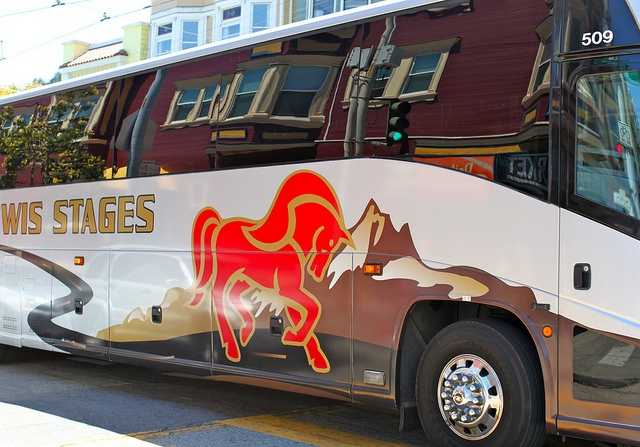Describe the objects in this image and their specific colors. I can see bus in white, black, lightgray, gray, and maroon tones and horse in white, red, tan, orange, and salmon tones in this image. 